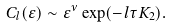Convert formula to latex. <formula><loc_0><loc_0><loc_500><loc_500>C _ { l } ( \varepsilon ) \sim \varepsilon ^ { \nu } \exp ( - l \tau K _ { 2 } ) .</formula> 